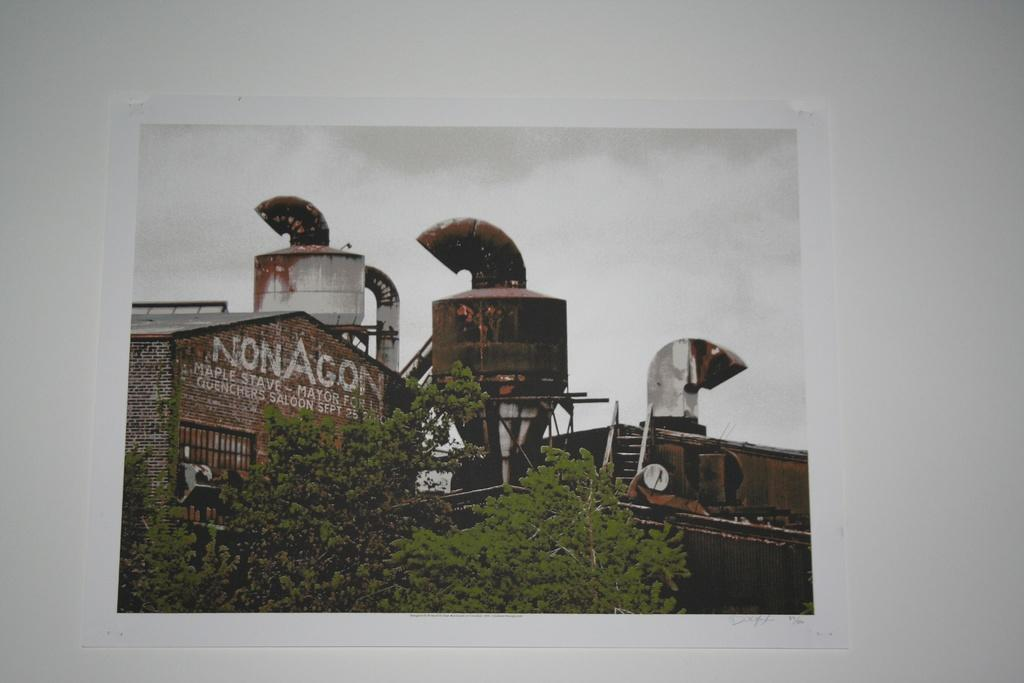<image>
Offer a succinct explanation of the picture presented. An old brick factory with the company name NonAgon in white letters written on it. 